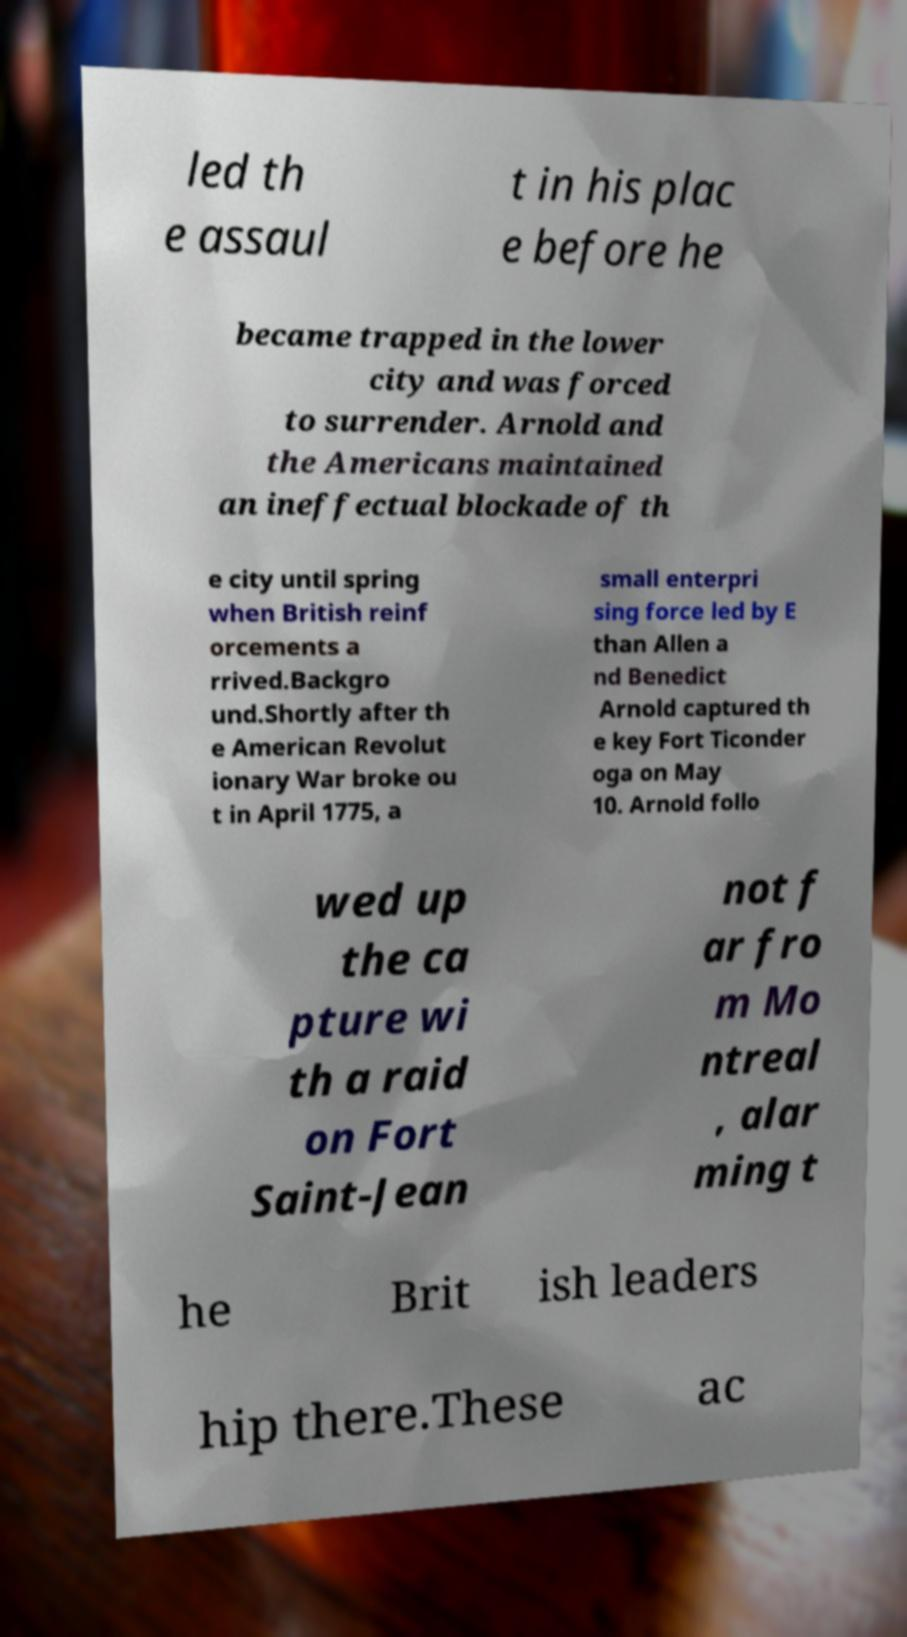Can you accurately transcribe the text from the provided image for me? led th e assaul t in his plac e before he became trapped in the lower city and was forced to surrender. Arnold and the Americans maintained an ineffectual blockade of th e city until spring when British reinf orcements a rrived.Backgro und.Shortly after th e American Revolut ionary War broke ou t in April 1775, a small enterpri sing force led by E than Allen a nd Benedict Arnold captured th e key Fort Ticonder oga on May 10. Arnold follo wed up the ca pture wi th a raid on Fort Saint-Jean not f ar fro m Mo ntreal , alar ming t he Brit ish leaders hip there.These ac 